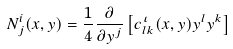Convert formula to latex. <formula><loc_0><loc_0><loc_500><loc_500>N _ { j } ^ { i } ( x , y ) = \frac { 1 } { 4 } \frac { \partial } { \partial y ^ { j } } \left [ c _ { l k } ^ { \iota } ( x , y ) y ^ { l } y ^ { k } \right ]</formula> 